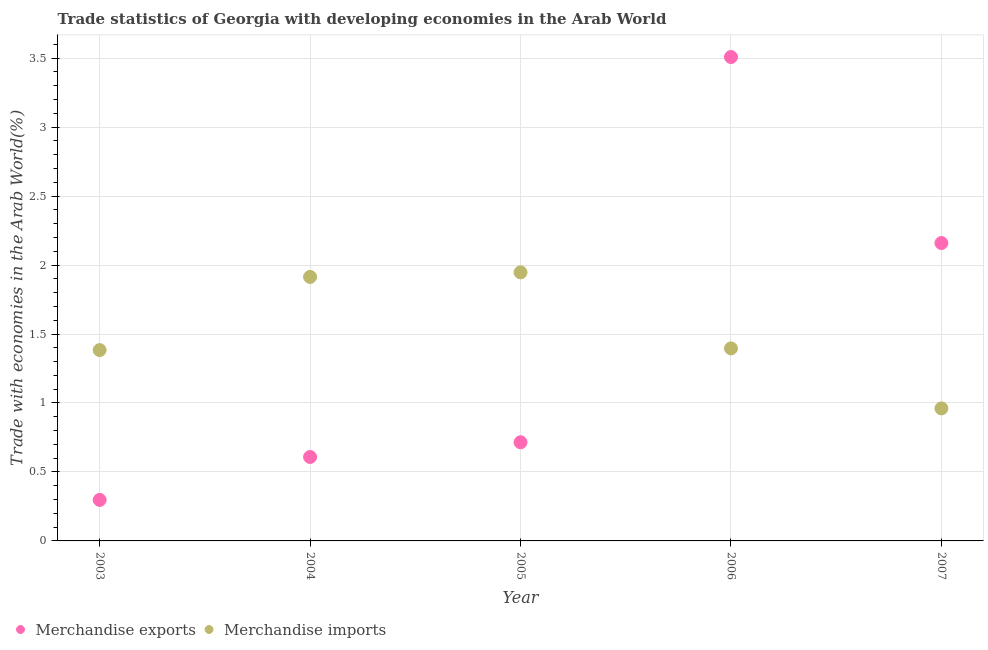Is the number of dotlines equal to the number of legend labels?
Provide a succinct answer. Yes. What is the merchandise exports in 2004?
Provide a succinct answer. 0.61. Across all years, what is the maximum merchandise imports?
Ensure brevity in your answer.  1.95. Across all years, what is the minimum merchandise imports?
Give a very brief answer. 0.96. In which year was the merchandise exports maximum?
Provide a short and direct response. 2006. In which year was the merchandise exports minimum?
Make the answer very short. 2003. What is the total merchandise exports in the graph?
Your answer should be compact. 7.29. What is the difference between the merchandise exports in 2003 and that in 2007?
Make the answer very short. -1.86. What is the difference between the merchandise imports in 2007 and the merchandise exports in 2005?
Your response must be concise. 0.25. What is the average merchandise imports per year?
Offer a very short reply. 1.52. In the year 2004, what is the difference between the merchandise exports and merchandise imports?
Your response must be concise. -1.31. What is the ratio of the merchandise exports in 2003 to that in 2007?
Your response must be concise. 0.14. Is the difference between the merchandise exports in 2003 and 2004 greater than the difference between the merchandise imports in 2003 and 2004?
Keep it short and to the point. Yes. What is the difference between the highest and the second highest merchandise imports?
Offer a terse response. 0.03. What is the difference between the highest and the lowest merchandise imports?
Offer a very short reply. 0.99. Is the merchandise imports strictly less than the merchandise exports over the years?
Your answer should be compact. No. How many years are there in the graph?
Give a very brief answer. 5. Are the values on the major ticks of Y-axis written in scientific E-notation?
Ensure brevity in your answer.  No. Does the graph contain any zero values?
Your answer should be very brief. No. Where does the legend appear in the graph?
Make the answer very short. Bottom left. How many legend labels are there?
Offer a terse response. 2. What is the title of the graph?
Make the answer very short. Trade statistics of Georgia with developing economies in the Arab World. Does "Investment" appear as one of the legend labels in the graph?
Provide a succinct answer. No. What is the label or title of the Y-axis?
Provide a short and direct response. Trade with economies in the Arab World(%). What is the Trade with economies in the Arab World(%) in Merchandise exports in 2003?
Offer a terse response. 0.3. What is the Trade with economies in the Arab World(%) of Merchandise imports in 2003?
Keep it short and to the point. 1.38. What is the Trade with economies in the Arab World(%) in Merchandise exports in 2004?
Your answer should be compact. 0.61. What is the Trade with economies in the Arab World(%) in Merchandise imports in 2004?
Your answer should be very brief. 1.91. What is the Trade with economies in the Arab World(%) in Merchandise exports in 2005?
Keep it short and to the point. 0.72. What is the Trade with economies in the Arab World(%) of Merchandise imports in 2005?
Your answer should be very brief. 1.95. What is the Trade with economies in the Arab World(%) in Merchandise exports in 2006?
Ensure brevity in your answer.  3.51. What is the Trade with economies in the Arab World(%) of Merchandise imports in 2006?
Keep it short and to the point. 1.4. What is the Trade with economies in the Arab World(%) of Merchandise exports in 2007?
Your answer should be very brief. 2.16. What is the Trade with economies in the Arab World(%) in Merchandise imports in 2007?
Give a very brief answer. 0.96. Across all years, what is the maximum Trade with economies in the Arab World(%) of Merchandise exports?
Make the answer very short. 3.51. Across all years, what is the maximum Trade with economies in the Arab World(%) of Merchandise imports?
Your answer should be very brief. 1.95. Across all years, what is the minimum Trade with economies in the Arab World(%) of Merchandise exports?
Your answer should be compact. 0.3. Across all years, what is the minimum Trade with economies in the Arab World(%) of Merchandise imports?
Your answer should be compact. 0.96. What is the total Trade with economies in the Arab World(%) of Merchandise exports in the graph?
Offer a terse response. 7.29. What is the total Trade with economies in the Arab World(%) in Merchandise imports in the graph?
Offer a very short reply. 7.6. What is the difference between the Trade with economies in the Arab World(%) of Merchandise exports in 2003 and that in 2004?
Your answer should be very brief. -0.31. What is the difference between the Trade with economies in the Arab World(%) in Merchandise imports in 2003 and that in 2004?
Provide a short and direct response. -0.53. What is the difference between the Trade with economies in the Arab World(%) in Merchandise exports in 2003 and that in 2005?
Give a very brief answer. -0.42. What is the difference between the Trade with economies in the Arab World(%) of Merchandise imports in 2003 and that in 2005?
Provide a short and direct response. -0.56. What is the difference between the Trade with economies in the Arab World(%) of Merchandise exports in 2003 and that in 2006?
Keep it short and to the point. -3.21. What is the difference between the Trade with economies in the Arab World(%) in Merchandise imports in 2003 and that in 2006?
Your answer should be very brief. -0.01. What is the difference between the Trade with economies in the Arab World(%) of Merchandise exports in 2003 and that in 2007?
Make the answer very short. -1.86. What is the difference between the Trade with economies in the Arab World(%) of Merchandise imports in 2003 and that in 2007?
Make the answer very short. 0.42. What is the difference between the Trade with economies in the Arab World(%) of Merchandise exports in 2004 and that in 2005?
Provide a short and direct response. -0.11. What is the difference between the Trade with economies in the Arab World(%) of Merchandise imports in 2004 and that in 2005?
Provide a short and direct response. -0.03. What is the difference between the Trade with economies in the Arab World(%) in Merchandise exports in 2004 and that in 2006?
Make the answer very short. -2.9. What is the difference between the Trade with economies in the Arab World(%) of Merchandise imports in 2004 and that in 2006?
Keep it short and to the point. 0.52. What is the difference between the Trade with economies in the Arab World(%) of Merchandise exports in 2004 and that in 2007?
Give a very brief answer. -1.55. What is the difference between the Trade with economies in the Arab World(%) in Merchandise imports in 2004 and that in 2007?
Your answer should be very brief. 0.95. What is the difference between the Trade with economies in the Arab World(%) of Merchandise exports in 2005 and that in 2006?
Your response must be concise. -2.79. What is the difference between the Trade with economies in the Arab World(%) of Merchandise imports in 2005 and that in 2006?
Your answer should be compact. 0.55. What is the difference between the Trade with economies in the Arab World(%) in Merchandise exports in 2005 and that in 2007?
Offer a very short reply. -1.44. What is the difference between the Trade with economies in the Arab World(%) in Merchandise imports in 2005 and that in 2007?
Offer a very short reply. 0.99. What is the difference between the Trade with economies in the Arab World(%) in Merchandise exports in 2006 and that in 2007?
Keep it short and to the point. 1.35. What is the difference between the Trade with economies in the Arab World(%) in Merchandise imports in 2006 and that in 2007?
Your answer should be compact. 0.43. What is the difference between the Trade with economies in the Arab World(%) of Merchandise exports in 2003 and the Trade with economies in the Arab World(%) of Merchandise imports in 2004?
Offer a very short reply. -1.62. What is the difference between the Trade with economies in the Arab World(%) in Merchandise exports in 2003 and the Trade with economies in the Arab World(%) in Merchandise imports in 2005?
Your answer should be very brief. -1.65. What is the difference between the Trade with economies in the Arab World(%) of Merchandise exports in 2003 and the Trade with economies in the Arab World(%) of Merchandise imports in 2006?
Your answer should be very brief. -1.1. What is the difference between the Trade with economies in the Arab World(%) of Merchandise exports in 2003 and the Trade with economies in the Arab World(%) of Merchandise imports in 2007?
Your answer should be compact. -0.66. What is the difference between the Trade with economies in the Arab World(%) in Merchandise exports in 2004 and the Trade with economies in the Arab World(%) in Merchandise imports in 2005?
Offer a terse response. -1.34. What is the difference between the Trade with economies in the Arab World(%) of Merchandise exports in 2004 and the Trade with economies in the Arab World(%) of Merchandise imports in 2006?
Provide a succinct answer. -0.79. What is the difference between the Trade with economies in the Arab World(%) of Merchandise exports in 2004 and the Trade with economies in the Arab World(%) of Merchandise imports in 2007?
Keep it short and to the point. -0.35. What is the difference between the Trade with economies in the Arab World(%) in Merchandise exports in 2005 and the Trade with economies in the Arab World(%) in Merchandise imports in 2006?
Provide a succinct answer. -0.68. What is the difference between the Trade with economies in the Arab World(%) in Merchandise exports in 2005 and the Trade with economies in the Arab World(%) in Merchandise imports in 2007?
Offer a very short reply. -0.25. What is the difference between the Trade with economies in the Arab World(%) in Merchandise exports in 2006 and the Trade with economies in the Arab World(%) in Merchandise imports in 2007?
Ensure brevity in your answer.  2.55. What is the average Trade with economies in the Arab World(%) in Merchandise exports per year?
Your answer should be compact. 1.46. What is the average Trade with economies in the Arab World(%) of Merchandise imports per year?
Give a very brief answer. 1.52. In the year 2003, what is the difference between the Trade with economies in the Arab World(%) in Merchandise exports and Trade with economies in the Arab World(%) in Merchandise imports?
Provide a succinct answer. -1.09. In the year 2004, what is the difference between the Trade with economies in the Arab World(%) of Merchandise exports and Trade with economies in the Arab World(%) of Merchandise imports?
Ensure brevity in your answer.  -1.31. In the year 2005, what is the difference between the Trade with economies in the Arab World(%) in Merchandise exports and Trade with economies in the Arab World(%) in Merchandise imports?
Your answer should be compact. -1.23. In the year 2006, what is the difference between the Trade with economies in the Arab World(%) of Merchandise exports and Trade with economies in the Arab World(%) of Merchandise imports?
Offer a terse response. 2.11. In the year 2007, what is the difference between the Trade with economies in the Arab World(%) of Merchandise exports and Trade with economies in the Arab World(%) of Merchandise imports?
Your answer should be compact. 1.2. What is the ratio of the Trade with economies in the Arab World(%) of Merchandise exports in 2003 to that in 2004?
Ensure brevity in your answer.  0.49. What is the ratio of the Trade with economies in the Arab World(%) in Merchandise imports in 2003 to that in 2004?
Your answer should be compact. 0.72. What is the ratio of the Trade with economies in the Arab World(%) in Merchandise exports in 2003 to that in 2005?
Ensure brevity in your answer.  0.42. What is the ratio of the Trade with economies in the Arab World(%) of Merchandise imports in 2003 to that in 2005?
Your response must be concise. 0.71. What is the ratio of the Trade with economies in the Arab World(%) of Merchandise exports in 2003 to that in 2006?
Provide a short and direct response. 0.08. What is the ratio of the Trade with economies in the Arab World(%) of Merchandise imports in 2003 to that in 2006?
Keep it short and to the point. 0.99. What is the ratio of the Trade with economies in the Arab World(%) in Merchandise exports in 2003 to that in 2007?
Offer a terse response. 0.14. What is the ratio of the Trade with economies in the Arab World(%) of Merchandise imports in 2003 to that in 2007?
Your response must be concise. 1.44. What is the ratio of the Trade with economies in the Arab World(%) of Merchandise exports in 2004 to that in 2005?
Your answer should be compact. 0.85. What is the ratio of the Trade with economies in the Arab World(%) of Merchandise exports in 2004 to that in 2006?
Your answer should be very brief. 0.17. What is the ratio of the Trade with economies in the Arab World(%) in Merchandise imports in 2004 to that in 2006?
Give a very brief answer. 1.37. What is the ratio of the Trade with economies in the Arab World(%) of Merchandise exports in 2004 to that in 2007?
Offer a very short reply. 0.28. What is the ratio of the Trade with economies in the Arab World(%) of Merchandise imports in 2004 to that in 2007?
Make the answer very short. 1.99. What is the ratio of the Trade with economies in the Arab World(%) of Merchandise exports in 2005 to that in 2006?
Provide a succinct answer. 0.2. What is the ratio of the Trade with economies in the Arab World(%) in Merchandise imports in 2005 to that in 2006?
Offer a terse response. 1.39. What is the ratio of the Trade with economies in the Arab World(%) of Merchandise exports in 2005 to that in 2007?
Your response must be concise. 0.33. What is the ratio of the Trade with economies in the Arab World(%) in Merchandise imports in 2005 to that in 2007?
Keep it short and to the point. 2.03. What is the ratio of the Trade with economies in the Arab World(%) of Merchandise exports in 2006 to that in 2007?
Your answer should be very brief. 1.62. What is the ratio of the Trade with economies in the Arab World(%) of Merchandise imports in 2006 to that in 2007?
Give a very brief answer. 1.45. What is the difference between the highest and the second highest Trade with economies in the Arab World(%) of Merchandise exports?
Your response must be concise. 1.35. What is the difference between the highest and the second highest Trade with economies in the Arab World(%) of Merchandise imports?
Your answer should be very brief. 0.03. What is the difference between the highest and the lowest Trade with economies in the Arab World(%) of Merchandise exports?
Give a very brief answer. 3.21. What is the difference between the highest and the lowest Trade with economies in the Arab World(%) in Merchandise imports?
Offer a terse response. 0.99. 